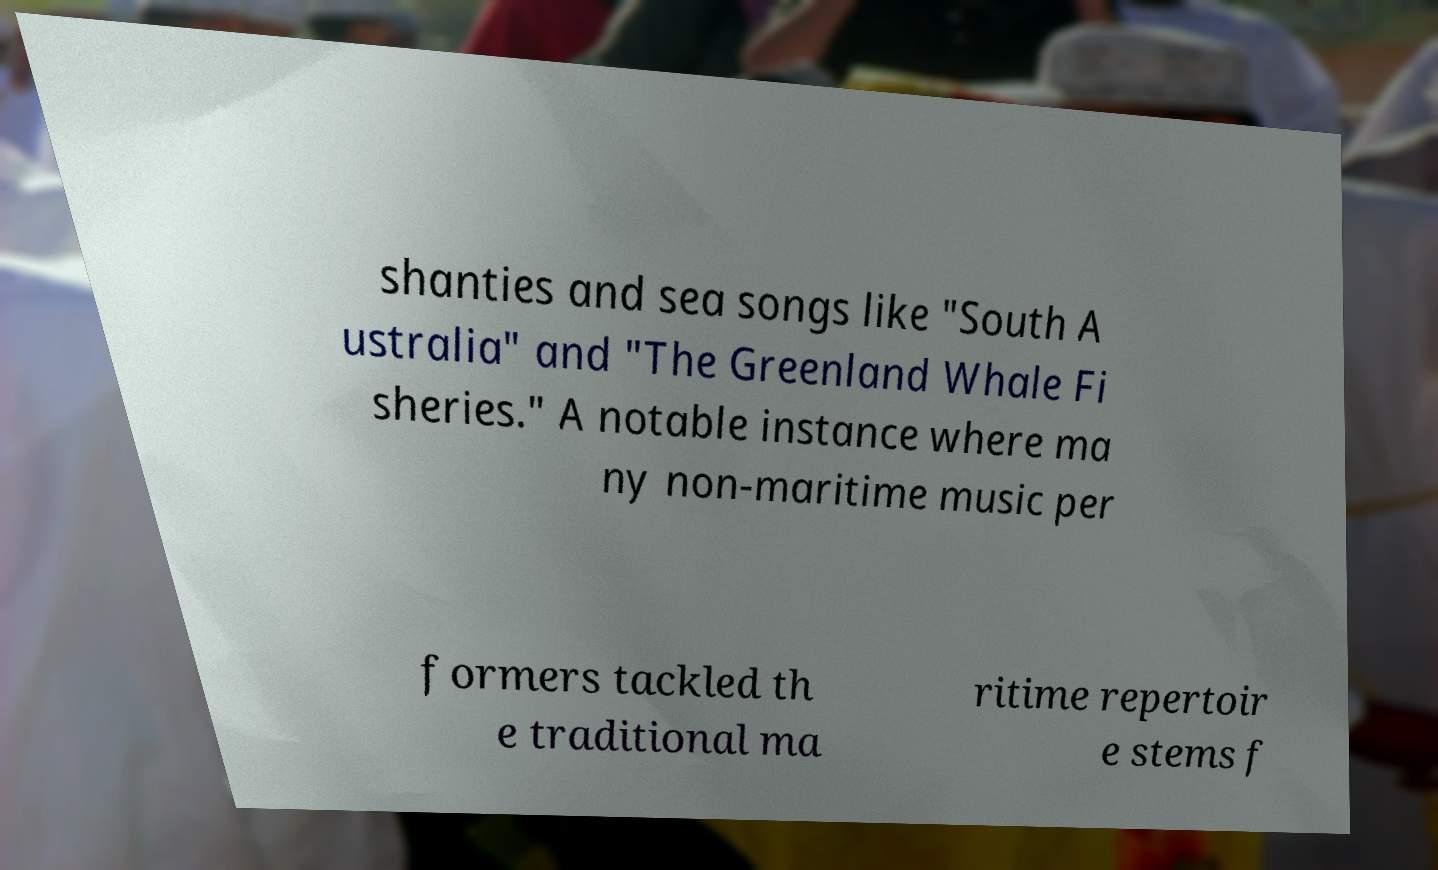Can you accurately transcribe the text from the provided image for me? shanties and sea songs like "South A ustralia" and "The Greenland Whale Fi sheries." A notable instance where ma ny non-maritime music per formers tackled th e traditional ma ritime repertoir e stems f 